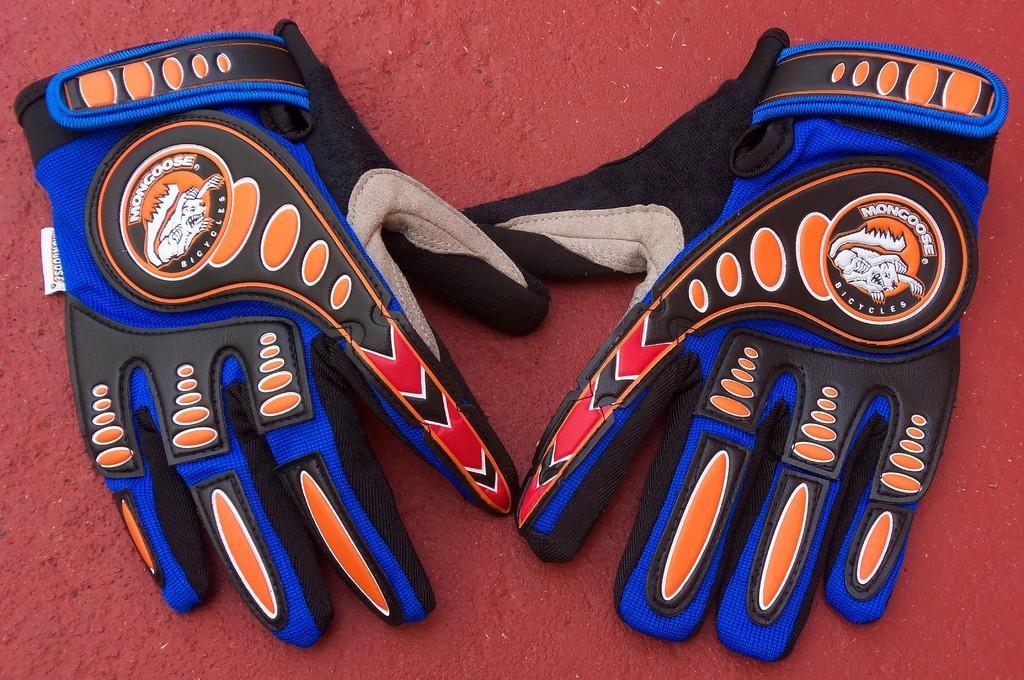Can you describe this image briefly? In this picture we can observe a pair of gloves which are in blue, black, red and orange colors. These gloves are placed on the red color surface. 